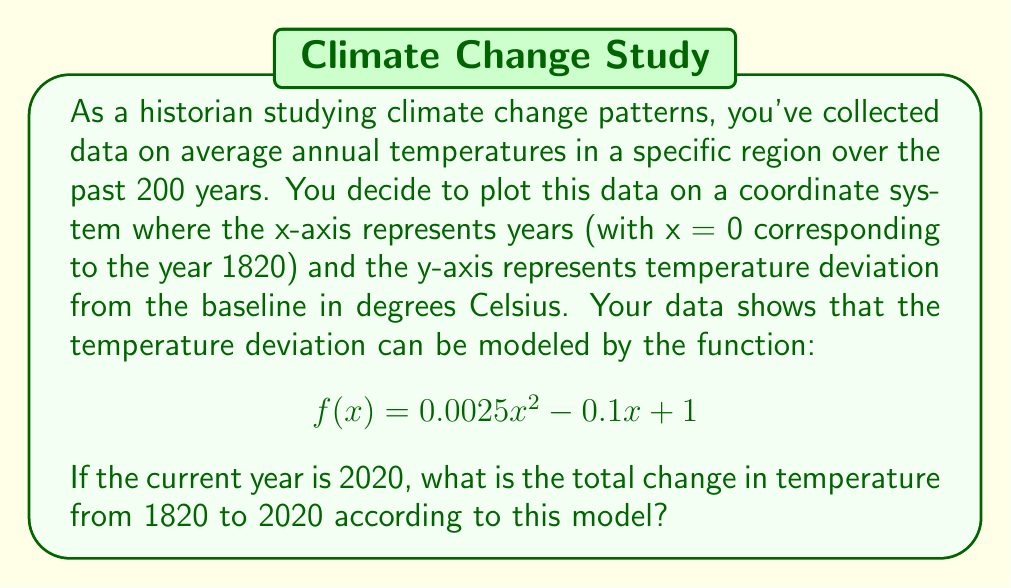Show me your answer to this math problem. To solve this problem, we need to follow these steps:

1. Identify the years we're comparing:
   - 1820 corresponds to x = 0
   - 2020 corresponds to x = 200 (since 2020 - 1820 = 200)

2. Calculate the temperature deviation for 1820 (x = 0):
   $$f(0) = 0.0025(0)^2 - 0.1(0) + 1 = 1°C$$

3. Calculate the temperature deviation for 2020 (x = 200):
   $$f(200) = 0.0025(200)^2 - 0.1(200) + 1$$
   $$= 100 - 20 + 1 = 81°C$$

4. Calculate the difference between these two values:
   $$\text{Total change} = f(200) - f(0) = 81 - 1 = 80°C$$

This result shows a significant increase in temperature over the 200-year period, which aligns with the concept of global warming and climate change. As a historian and environmental advocate, you would likely find this trend concerning and use it to support arguments for climate action.
Answer: The total change in temperature from 1820 to 2020 according to the model is 80°C. 